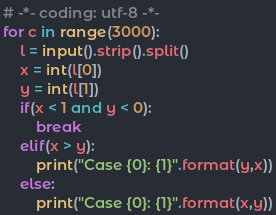Convert code to text. <code><loc_0><loc_0><loc_500><loc_500><_Python_># -*- coding: utf-8 -*-
for c in range(3000):
    l = input().strip().split()
    x = int(l[0])
    y = int(l[1])
    if(x < 1 and y < 0):
        break
    elif(x > y):
        print("Case {0}: {1}".format(y,x))
    else:
        print("Case {0}: {1}".format(x,y))</code> 